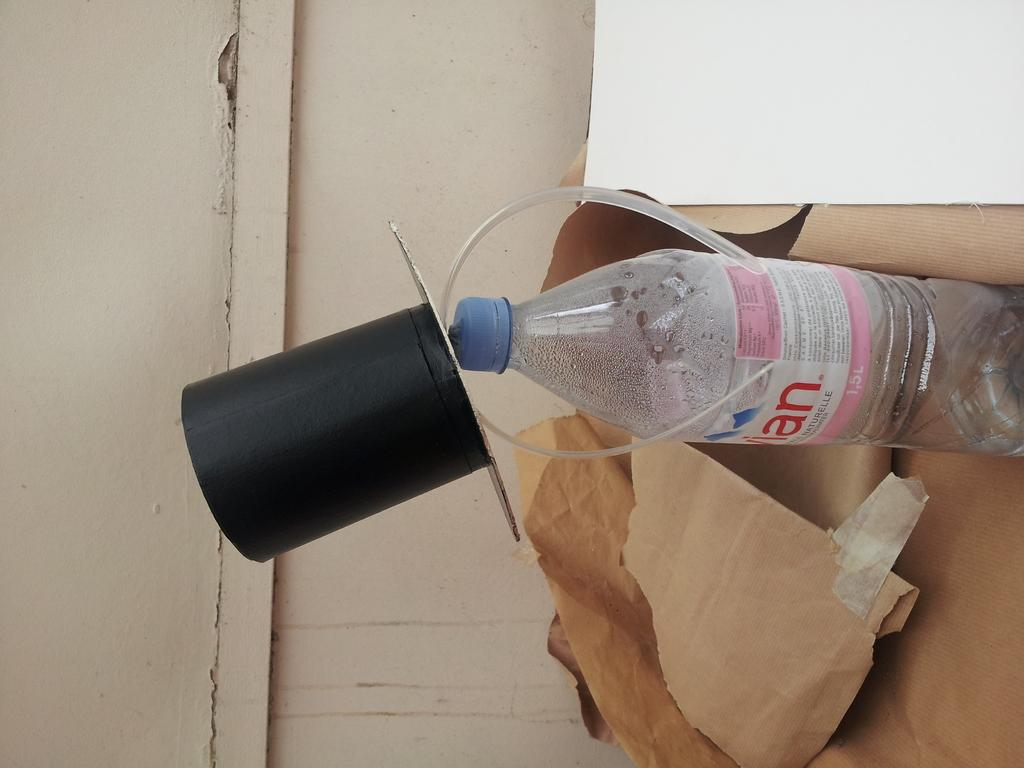<image>
Describe the image concisely. A bottle with a blue cap contains 1,5L of water. 